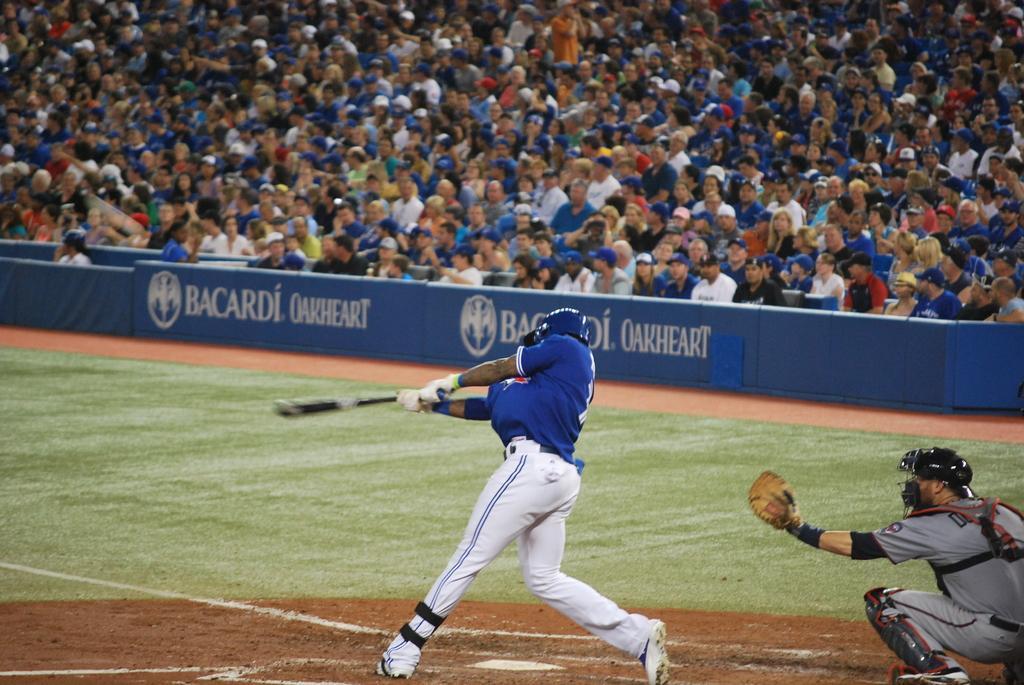Please provide a concise description of this image. The picture is clicked in a baseball court. In the center of the picture there is a person holding bat. on the right it is keeper. At the bottom there is red soil. In the center there are banners and grass. At the top there are audience in the stadium. 